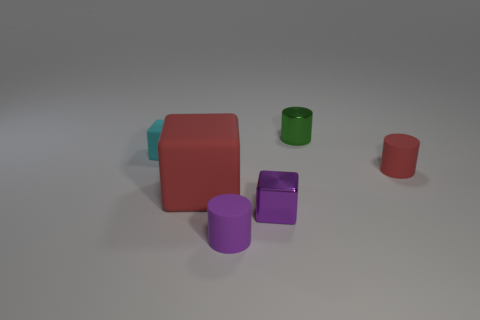Are there more metal objects on the left side of the big thing than matte things?
Your answer should be compact. No. There is a large red thing that is the same material as the small red object; what is its shape?
Your answer should be very brief. Cube. There is a cylinder that is to the right of the green object; is its size the same as the metal block?
Give a very brief answer. Yes. There is a tiny matte object that is in front of the small red matte object that is behind the small metallic block; what shape is it?
Your response must be concise. Cylinder. There is a matte thing left of the big thing that is in front of the red matte cylinder; how big is it?
Offer a terse response. Small. There is a small shiny thing in front of the cyan rubber object; what is its color?
Provide a short and direct response. Purple. What size is the block that is made of the same material as the tiny green object?
Your answer should be compact. Small. What number of tiny purple metallic things have the same shape as the purple rubber object?
Keep it short and to the point. 0. What material is the red object that is the same size as the green shiny cylinder?
Offer a very short reply. Rubber. Are there any tiny green blocks that have the same material as the tiny purple block?
Provide a short and direct response. No. 